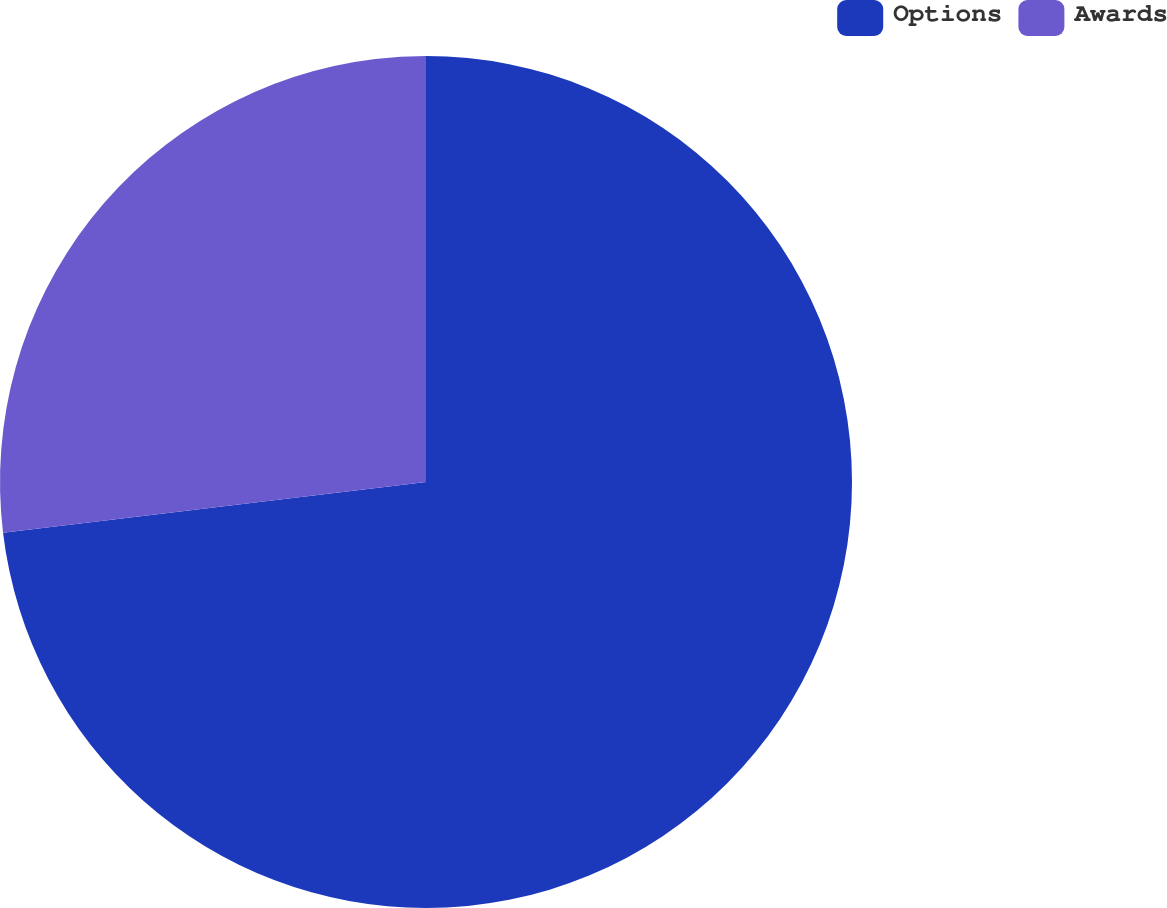<chart> <loc_0><loc_0><loc_500><loc_500><pie_chart><fcel>Options<fcel>Awards<nl><fcel>73.1%<fcel>26.9%<nl></chart> 